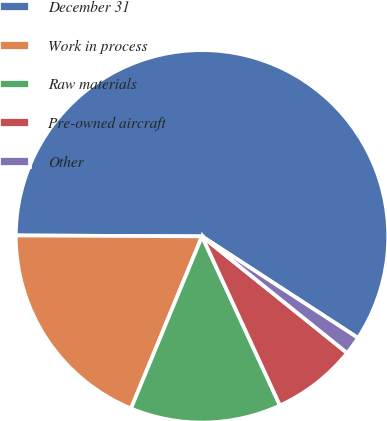Convert chart. <chart><loc_0><loc_0><loc_500><loc_500><pie_chart><fcel>December 31<fcel>Work in process<fcel>Raw materials<fcel>Pre-owned aircraft<fcel>Other<nl><fcel>59.11%<fcel>18.85%<fcel>13.1%<fcel>7.35%<fcel>1.59%<nl></chart> 